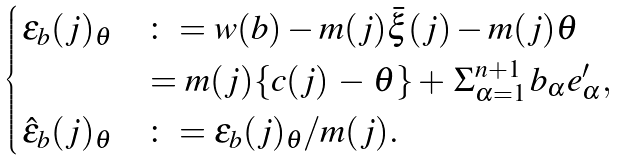Convert formula to latex. <formula><loc_0><loc_0><loc_500><loc_500>\begin{cases} \, \epsilon _ { b } ( j ) _ { \theta } & \colon = w ( b ) - m ( j ) \bar { \xi } ( j ) - m ( j ) \theta \\ & \, = m ( j ) \{ c ( j ) \, - \, \theta \} + \, \Sigma _ { \alpha = 1 } ^ { n + 1 } \, b _ { \alpha } e ^ { \prime } _ { \alpha } , \\ \, \hat { \epsilon } _ { b } ( j ) _ { \theta } & \colon = \epsilon _ { b } ( j ) _ { \theta } / m ( j ) . \end{cases}</formula> 